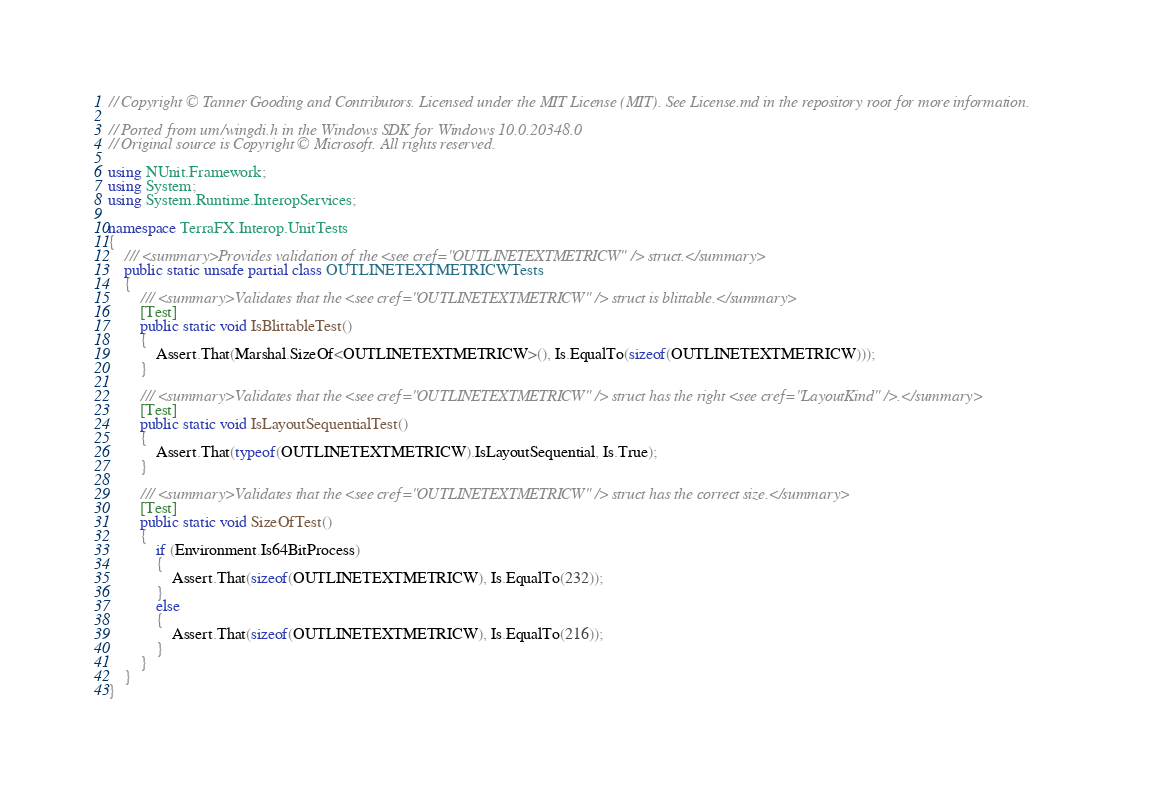<code> <loc_0><loc_0><loc_500><loc_500><_C#_>// Copyright © Tanner Gooding and Contributors. Licensed under the MIT License (MIT). See License.md in the repository root for more information.

// Ported from um/wingdi.h in the Windows SDK for Windows 10.0.20348.0
// Original source is Copyright © Microsoft. All rights reserved.

using NUnit.Framework;
using System;
using System.Runtime.InteropServices;

namespace TerraFX.Interop.UnitTests
{
    /// <summary>Provides validation of the <see cref="OUTLINETEXTMETRICW" /> struct.</summary>
    public static unsafe partial class OUTLINETEXTMETRICWTests
    {
        /// <summary>Validates that the <see cref="OUTLINETEXTMETRICW" /> struct is blittable.</summary>
        [Test]
        public static void IsBlittableTest()
        {
            Assert.That(Marshal.SizeOf<OUTLINETEXTMETRICW>(), Is.EqualTo(sizeof(OUTLINETEXTMETRICW)));
        }

        /// <summary>Validates that the <see cref="OUTLINETEXTMETRICW" /> struct has the right <see cref="LayoutKind" />.</summary>
        [Test]
        public static void IsLayoutSequentialTest()
        {
            Assert.That(typeof(OUTLINETEXTMETRICW).IsLayoutSequential, Is.True);
        }

        /// <summary>Validates that the <see cref="OUTLINETEXTMETRICW" /> struct has the correct size.</summary>
        [Test]
        public static void SizeOfTest()
        {
            if (Environment.Is64BitProcess)
            {
                Assert.That(sizeof(OUTLINETEXTMETRICW), Is.EqualTo(232));
            }
            else
            {
                Assert.That(sizeof(OUTLINETEXTMETRICW), Is.EqualTo(216));
            }
        }
    }
}
</code> 